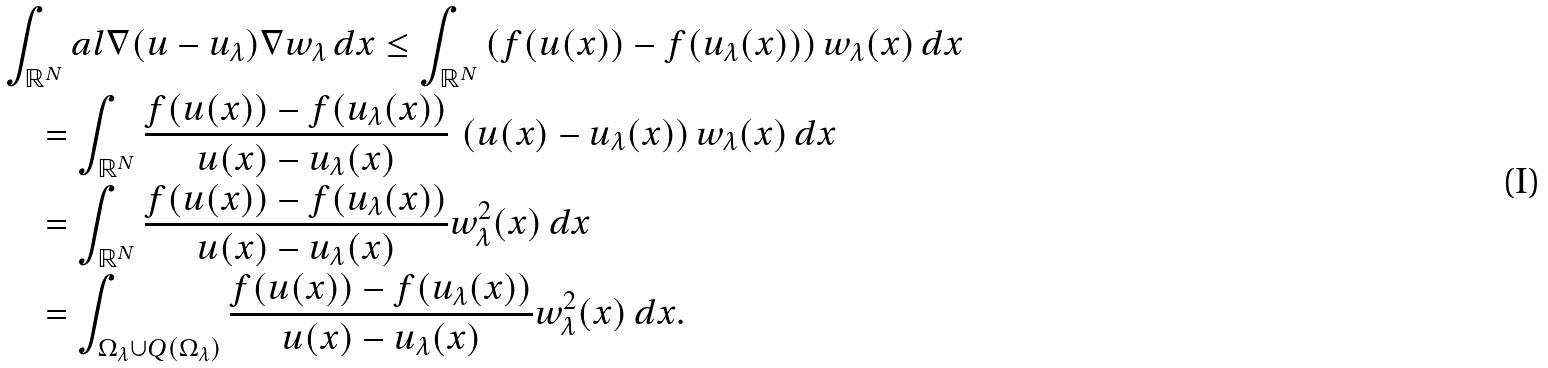Convert formula to latex. <formula><loc_0><loc_0><loc_500><loc_500>& \int _ { \mathbb { R } ^ { N } } a l { \nabla ( u - u _ { \lambda } ) } { \nabla w _ { \lambda } } \, d x \leq \int _ { \mathbb { R } ^ { N } } \left ( f ( u ( x ) ) - f ( u _ { \lambda } ( x ) ) \right ) w _ { \lambda } ( x ) \, d x \\ & \quad = \int _ { \mathbb { R } ^ { N } } \frac { f ( u ( x ) ) - f ( u _ { \lambda } ( x ) ) } { u ( x ) - u _ { \lambda } ( x ) } \, \left ( u ( x ) - u _ { \lambda } ( x ) \right ) w _ { \lambda } ( x ) \, d x \\ & \quad = \int _ { \mathbb { R } ^ { N } } \frac { f ( u ( x ) ) - f ( u _ { \lambda } ( x ) ) } { u ( x ) - u _ { \lambda } ( x ) } w _ { \lambda } ^ { 2 } ( x ) \, d x \\ & \quad = \int _ { \Omega _ { \lambda } \cup Q ( \Omega _ { \lambda } ) } \frac { f ( u ( x ) ) - f ( u _ { \lambda } ( x ) ) } { u ( x ) - u _ { \lambda } ( x ) } w _ { \lambda } ^ { 2 } ( x ) \, d x .</formula> 